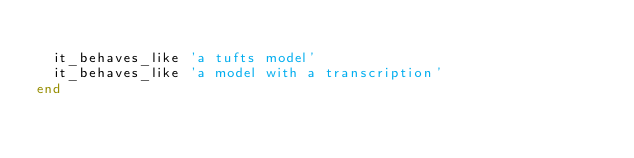Convert code to text. <code><loc_0><loc_0><loc_500><loc_500><_Ruby_>
  it_behaves_like 'a tufts model'
  it_behaves_like 'a model with a transcription'
end
</code> 